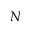<formula> <loc_0><loc_0><loc_500><loc_500>N</formula> 